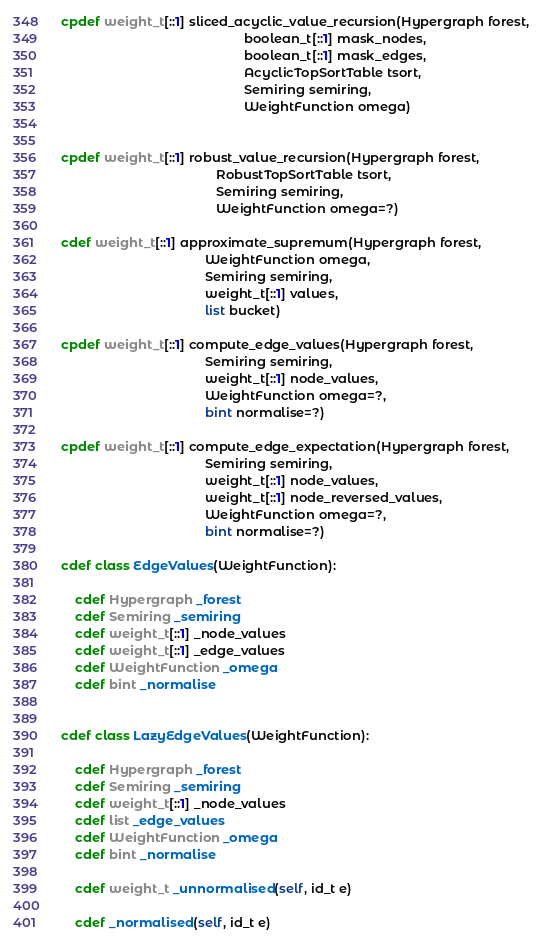Convert code to text. <code><loc_0><loc_0><loc_500><loc_500><_Cython_>

cpdef weight_t[::1] sliced_acyclic_value_recursion(Hypergraph forest,
                                                   boolean_t[::1] mask_nodes,
                                                   boolean_t[::1] mask_edges,
                                                   AcyclicTopSortTable tsort,
                                                   Semiring semiring,
                                                   WeightFunction omega)


cpdef weight_t[::1] robust_value_recursion(Hypergraph forest,
                                           RobustTopSortTable tsort,
                                           Semiring semiring,
                                           WeightFunction omega=?)

cdef weight_t[::1] approximate_supremum(Hypergraph forest,
                                        WeightFunction omega,
                                        Semiring semiring,
                                        weight_t[::1] values,
                                        list bucket)

cpdef weight_t[::1] compute_edge_values(Hypergraph forest,
                                        Semiring semiring,
                                        weight_t[::1] node_values,
                                        WeightFunction omega=?,
                                        bint normalise=?)

cpdef weight_t[::1] compute_edge_expectation(Hypergraph forest,
                                        Semiring semiring,
                                        weight_t[::1] node_values,
                                        weight_t[::1] node_reversed_values,
                                        WeightFunction omega=?,
                                        bint normalise=?)

cdef class EdgeValues(WeightFunction):

    cdef Hypergraph _forest
    cdef Semiring _semiring
    cdef weight_t[::1] _node_values
    cdef weight_t[::1] _edge_values
    cdef WeightFunction _omega
    cdef bint _normalise


cdef class LazyEdgeValues(WeightFunction):

    cdef Hypergraph _forest
    cdef Semiring _semiring
    cdef weight_t[::1] _node_values
    cdef list _edge_values
    cdef WeightFunction _omega
    cdef bint _normalise

    cdef weight_t _unnormalised(self, id_t e)

    cdef _normalised(self, id_t e)
</code> 